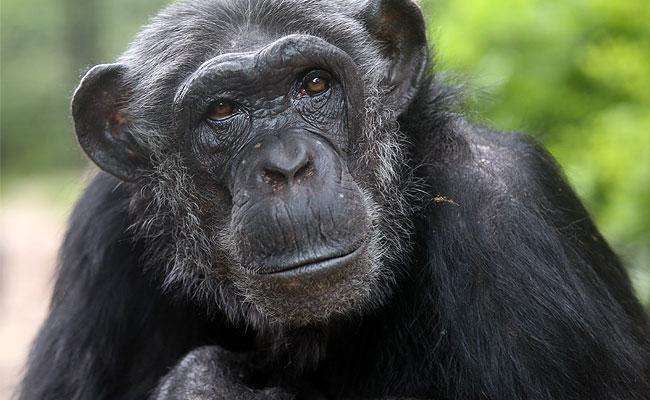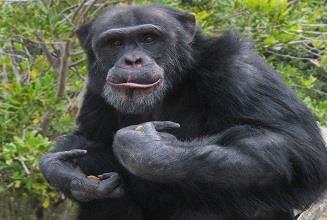The first image is the image on the left, the second image is the image on the right. Considering the images on both sides, is "The chimp in the right image is showing his teeth." valid? Answer yes or no. No. 